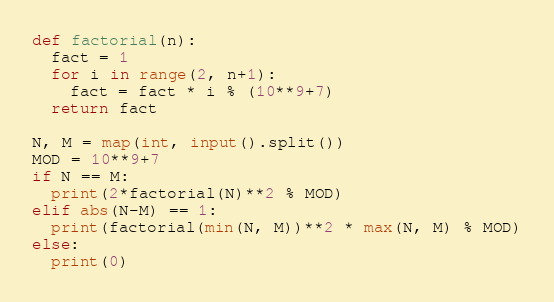<code> <loc_0><loc_0><loc_500><loc_500><_Python_>def factorial(n):
  fact = 1
  for i in range(2, n+1):
    fact = fact * i % (10**9+7)
  return fact

N, M = map(int, input().split())
MOD = 10**9+7
if N == M:
  print(2*factorial(N)**2 % MOD)
elif abs(N-M) == 1:
  print(factorial(min(N, M))**2 * max(N, M) % MOD)
else:
  print(0)</code> 